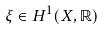<formula> <loc_0><loc_0><loc_500><loc_500>\xi \in H ^ { 1 } ( X , \mathbb { R } )</formula> 